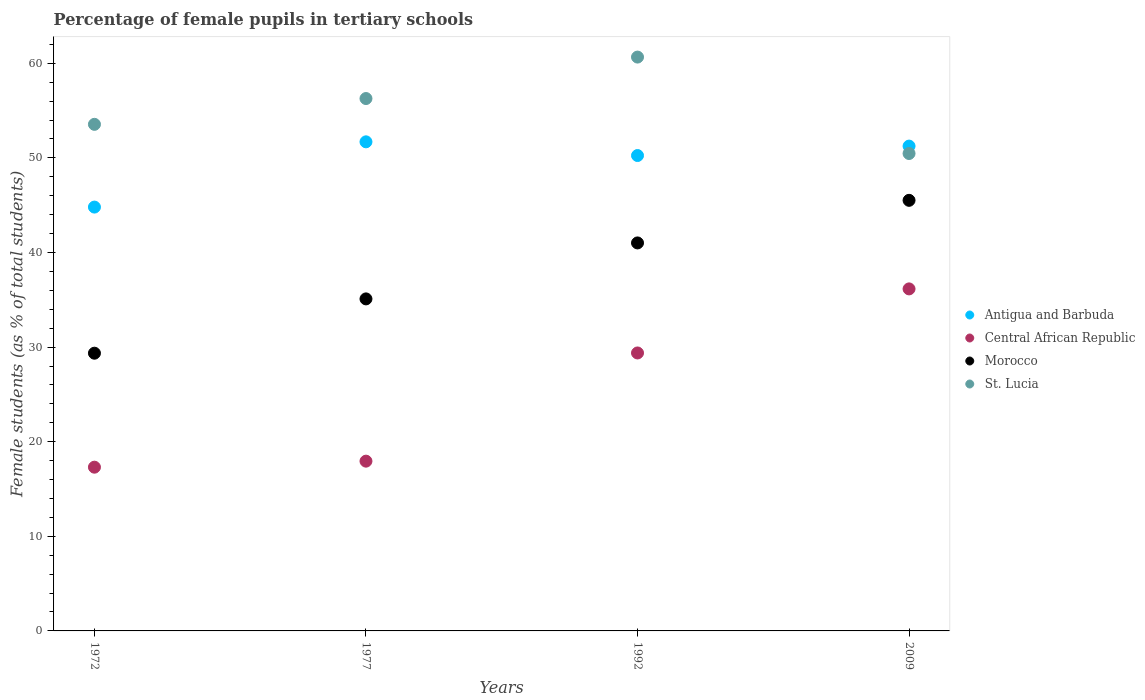How many different coloured dotlines are there?
Keep it short and to the point. 4. Is the number of dotlines equal to the number of legend labels?
Your answer should be compact. Yes. What is the percentage of female pupils in tertiary schools in Central African Republic in 1972?
Ensure brevity in your answer.  17.31. Across all years, what is the maximum percentage of female pupils in tertiary schools in Antigua and Barbuda?
Make the answer very short. 51.7. Across all years, what is the minimum percentage of female pupils in tertiary schools in Morocco?
Ensure brevity in your answer.  29.36. In which year was the percentage of female pupils in tertiary schools in Antigua and Barbuda maximum?
Make the answer very short. 1977. What is the total percentage of female pupils in tertiary schools in Morocco in the graph?
Keep it short and to the point. 150.97. What is the difference between the percentage of female pupils in tertiary schools in St. Lucia in 1972 and that in 1992?
Offer a very short reply. -7.11. What is the difference between the percentage of female pupils in tertiary schools in Antigua and Barbuda in 1992 and the percentage of female pupils in tertiary schools in Central African Republic in 1972?
Make the answer very short. 32.94. What is the average percentage of female pupils in tertiary schools in Central African Republic per year?
Offer a terse response. 25.2. In the year 1972, what is the difference between the percentage of female pupils in tertiary schools in Morocco and percentage of female pupils in tertiary schools in St. Lucia?
Make the answer very short. -24.19. What is the ratio of the percentage of female pupils in tertiary schools in Morocco in 1992 to that in 2009?
Offer a very short reply. 0.9. What is the difference between the highest and the second highest percentage of female pupils in tertiary schools in Central African Republic?
Ensure brevity in your answer.  6.77. What is the difference between the highest and the lowest percentage of female pupils in tertiary schools in Morocco?
Keep it short and to the point. 16.16. In how many years, is the percentage of female pupils in tertiary schools in Morocco greater than the average percentage of female pupils in tertiary schools in Morocco taken over all years?
Offer a terse response. 2. Is the sum of the percentage of female pupils in tertiary schools in Morocco in 1972 and 1977 greater than the maximum percentage of female pupils in tertiary schools in Central African Republic across all years?
Your answer should be very brief. Yes. Is it the case that in every year, the sum of the percentage of female pupils in tertiary schools in Morocco and percentage of female pupils in tertiary schools in Antigua and Barbuda  is greater than the sum of percentage of female pupils in tertiary schools in St. Lucia and percentage of female pupils in tertiary schools in Central African Republic?
Your answer should be very brief. No. Does the percentage of female pupils in tertiary schools in Central African Republic monotonically increase over the years?
Offer a terse response. Yes. Is the percentage of female pupils in tertiary schools in St. Lucia strictly greater than the percentage of female pupils in tertiary schools in Morocco over the years?
Offer a very short reply. Yes. Is the percentage of female pupils in tertiary schools in Morocco strictly less than the percentage of female pupils in tertiary schools in St. Lucia over the years?
Give a very brief answer. Yes. How many years are there in the graph?
Make the answer very short. 4. Are the values on the major ticks of Y-axis written in scientific E-notation?
Offer a very short reply. No. Does the graph contain any zero values?
Your answer should be very brief. No. Does the graph contain grids?
Offer a very short reply. No. Where does the legend appear in the graph?
Your response must be concise. Center right. What is the title of the graph?
Ensure brevity in your answer.  Percentage of female pupils in tertiary schools. Does "Spain" appear as one of the legend labels in the graph?
Your answer should be very brief. No. What is the label or title of the X-axis?
Provide a succinct answer. Years. What is the label or title of the Y-axis?
Your answer should be compact. Female students (as % of total students). What is the Female students (as % of total students) in Antigua and Barbuda in 1972?
Ensure brevity in your answer.  44.8. What is the Female students (as % of total students) of Central African Republic in 1972?
Keep it short and to the point. 17.31. What is the Female students (as % of total students) of Morocco in 1972?
Your response must be concise. 29.36. What is the Female students (as % of total students) in St. Lucia in 1972?
Give a very brief answer. 53.55. What is the Female students (as % of total students) in Antigua and Barbuda in 1977?
Offer a very short reply. 51.7. What is the Female students (as % of total students) in Central African Republic in 1977?
Ensure brevity in your answer.  17.94. What is the Female students (as % of total students) of Morocco in 1977?
Your answer should be compact. 35.09. What is the Female students (as % of total students) in St. Lucia in 1977?
Provide a short and direct response. 56.27. What is the Female students (as % of total students) of Antigua and Barbuda in 1992?
Your answer should be very brief. 50.25. What is the Female students (as % of total students) of Central African Republic in 1992?
Keep it short and to the point. 29.38. What is the Female students (as % of total students) of Morocco in 1992?
Make the answer very short. 41.01. What is the Female students (as % of total students) in St. Lucia in 1992?
Your answer should be very brief. 60.65. What is the Female students (as % of total students) of Antigua and Barbuda in 2009?
Give a very brief answer. 51.24. What is the Female students (as % of total students) of Central African Republic in 2009?
Ensure brevity in your answer.  36.15. What is the Female students (as % of total students) of Morocco in 2009?
Provide a succinct answer. 45.51. What is the Female students (as % of total students) in St. Lucia in 2009?
Provide a succinct answer. 50.46. Across all years, what is the maximum Female students (as % of total students) of Antigua and Barbuda?
Provide a short and direct response. 51.7. Across all years, what is the maximum Female students (as % of total students) of Central African Republic?
Offer a terse response. 36.15. Across all years, what is the maximum Female students (as % of total students) in Morocco?
Give a very brief answer. 45.51. Across all years, what is the maximum Female students (as % of total students) of St. Lucia?
Your response must be concise. 60.65. Across all years, what is the minimum Female students (as % of total students) in Antigua and Barbuda?
Offer a terse response. 44.8. Across all years, what is the minimum Female students (as % of total students) in Central African Republic?
Your response must be concise. 17.31. Across all years, what is the minimum Female students (as % of total students) of Morocco?
Offer a terse response. 29.36. Across all years, what is the minimum Female students (as % of total students) in St. Lucia?
Offer a very short reply. 50.46. What is the total Female students (as % of total students) in Antigua and Barbuda in the graph?
Offer a terse response. 197.99. What is the total Female students (as % of total students) of Central African Republic in the graph?
Keep it short and to the point. 100.78. What is the total Female students (as % of total students) in Morocco in the graph?
Give a very brief answer. 150.97. What is the total Female students (as % of total students) in St. Lucia in the graph?
Your response must be concise. 220.93. What is the difference between the Female students (as % of total students) of Antigua and Barbuda in 1972 and that in 1977?
Provide a succinct answer. -6.9. What is the difference between the Female students (as % of total students) of Central African Republic in 1972 and that in 1977?
Your answer should be very brief. -0.64. What is the difference between the Female students (as % of total students) in Morocco in 1972 and that in 1977?
Make the answer very short. -5.74. What is the difference between the Female students (as % of total students) of St. Lucia in 1972 and that in 1977?
Your response must be concise. -2.73. What is the difference between the Female students (as % of total students) in Antigua and Barbuda in 1972 and that in 1992?
Ensure brevity in your answer.  -5.45. What is the difference between the Female students (as % of total students) of Central African Republic in 1972 and that in 1992?
Your response must be concise. -12.07. What is the difference between the Female students (as % of total students) in Morocco in 1972 and that in 1992?
Offer a terse response. -11.66. What is the difference between the Female students (as % of total students) of St. Lucia in 1972 and that in 1992?
Provide a short and direct response. -7.11. What is the difference between the Female students (as % of total students) in Antigua and Barbuda in 1972 and that in 2009?
Provide a succinct answer. -6.45. What is the difference between the Female students (as % of total students) of Central African Republic in 1972 and that in 2009?
Make the answer very short. -18.84. What is the difference between the Female students (as % of total students) of Morocco in 1972 and that in 2009?
Your answer should be compact. -16.16. What is the difference between the Female students (as % of total students) in St. Lucia in 1972 and that in 2009?
Your answer should be very brief. 3.08. What is the difference between the Female students (as % of total students) in Antigua and Barbuda in 1977 and that in 1992?
Keep it short and to the point. 1.45. What is the difference between the Female students (as % of total students) of Central African Republic in 1977 and that in 1992?
Your answer should be compact. -11.44. What is the difference between the Female students (as % of total students) in Morocco in 1977 and that in 1992?
Your answer should be very brief. -5.92. What is the difference between the Female students (as % of total students) of St. Lucia in 1977 and that in 1992?
Provide a succinct answer. -4.38. What is the difference between the Female students (as % of total students) in Antigua and Barbuda in 1977 and that in 2009?
Offer a very short reply. 0.45. What is the difference between the Female students (as % of total students) of Central African Republic in 1977 and that in 2009?
Your answer should be very brief. -18.21. What is the difference between the Female students (as % of total students) in Morocco in 1977 and that in 2009?
Offer a very short reply. -10.42. What is the difference between the Female students (as % of total students) of St. Lucia in 1977 and that in 2009?
Offer a very short reply. 5.81. What is the difference between the Female students (as % of total students) in Antigua and Barbuda in 1992 and that in 2009?
Your answer should be compact. -1. What is the difference between the Female students (as % of total students) of Central African Republic in 1992 and that in 2009?
Provide a short and direct response. -6.77. What is the difference between the Female students (as % of total students) in Morocco in 1992 and that in 2009?
Make the answer very short. -4.5. What is the difference between the Female students (as % of total students) in St. Lucia in 1992 and that in 2009?
Give a very brief answer. 10.19. What is the difference between the Female students (as % of total students) in Antigua and Barbuda in 1972 and the Female students (as % of total students) in Central African Republic in 1977?
Your answer should be very brief. 26.85. What is the difference between the Female students (as % of total students) in Antigua and Barbuda in 1972 and the Female students (as % of total students) in Morocco in 1977?
Give a very brief answer. 9.7. What is the difference between the Female students (as % of total students) in Antigua and Barbuda in 1972 and the Female students (as % of total students) in St. Lucia in 1977?
Provide a short and direct response. -11.47. What is the difference between the Female students (as % of total students) in Central African Republic in 1972 and the Female students (as % of total students) in Morocco in 1977?
Keep it short and to the point. -17.79. What is the difference between the Female students (as % of total students) of Central African Republic in 1972 and the Female students (as % of total students) of St. Lucia in 1977?
Your answer should be compact. -38.97. What is the difference between the Female students (as % of total students) in Morocco in 1972 and the Female students (as % of total students) in St. Lucia in 1977?
Provide a succinct answer. -26.92. What is the difference between the Female students (as % of total students) in Antigua and Barbuda in 1972 and the Female students (as % of total students) in Central African Republic in 1992?
Give a very brief answer. 15.42. What is the difference between the Female students (as % of total students) in Antigua and Barbuda in 1972 and the Female students (as % of total students) in Morocco in 1992?
Offer a very short reply. 3.79. What is the difference between the Female students (as % of total students) in Antigua and Barbuda in 1972 and the Female students (as % of total students) in St. Lucia in 1992?
Make the answer very short. -15.86. What is the difference between the Female students (as % of total students) of Central African Republic in 1972 and the Female students (as % of total students) of Morocco in 1992?
Ensure brevity in your answer.  -23.7. What is the difference between the Female students (as % of total students) of Central African Republic in 1972 and the Female students (as % of total students) of St. Lucia in 1992?
Your response must be concise. -43.35. What is the difference between the Female students (as % of total students) in Morocco in 1972 and the Female students (as % of total students) in St. Lucia in 1992?
Offer a terse response. -31.3. What is the difference between the Female students (as % of total students) in Antigua and Barbuda in 1972 and the Female students (as % of total students) in Central African Republic in 2009?
Ensure brevity in your answer.  8.65. What is the difference between the Female students (as % of total students) of Antigua and Barbuda in 1972 and the Female students (as % of total students) of Morocco in 2009?
Offer a very short reply. -0.71. What is the difference between the Female students (as % of total students) of Antigua and Barbuda in 1972 and the Female students (as % of total students) of St. Lucia in 2009?
Your answer should be very brief. -5.66. What is the difference between the Female students (as % of total students) of Central African Republic in 1972 and the Female students (as % of total students) of Morocco in 2009?
Provide a short and direct response. -28.21. What is the difference between the Female students (as % of total students) of Central African Republic in 1972 and the Female students (as % of total students) of St. Lucia in 2009?
Offer a very short reply. -33.16. What is the difference between the Female students (as % of total students) in Morocco in 1972 and the Female students (as % of total students) in St. Lucia in 2009?
Offer a very short reply. -21.11. What is the difference between the Female students (as % of total students) of Antigua and Barbuda in 1977 and the Female students (as % of total students) of Central African Republic in 1992?
Ensure brevity in your answer.  22.32. What is the difference between the Female students (as % of total students) of Antigua and Barbuda in 1977 and the Female students (as % of total students) of Morocco in 1992?
Provide a short and direct response. 10.69. What is the difference between the Female students (as % of total students) of Antigua and Barbuda in 1977 and the Female students (as % of total students) of St. Lucia in 1992?
Your response must be concise. -8.96. What is the difference between the Female students (as % of total students) in Central African Republic in 1977 and the Female students (as % of total students) in Morocco in 1992?
Make the answer very short. -23.07. What is the difference between the Female students (as % of total students) in Central African Republic in 1977 and the Female students (as % of total students) in St. Lucia in 1992?
Give a very brief answer. -42.71. What is the difference between the Female students (as % of total students) in Morocco in 1977 and the Female students (as % of total students) in St. Lucia in 1992?
Ensure brevity in your answer.  -25.56. What is the difference between the Female students (as % of total students) in Antigua and Barbuda in 1977 and the Female students (as % of total students) in Central African Republic in 2009?
Keep it short and to the point. 15.54. What is the difference between the Female students (as % of total students) in Antigua and Barbuda in 1977 and the Female students (as % of total students) in Morocco in 2009?
Provide a succinct answer. 6.18. What is the difference between the Female students (as % of total students) of Antigua and Barbuda in 1977 and the Female students (as % of total students) of St. Lucia in 2009?
Ensure brevity in your answer.  1.23. What is the difference between the Female students (as % of total students) of Central African Republic in 1977 and the Female students (as % of total students) of Morocco in 2009?
Give a very brief answer. -27.57. What is the difference between the Female students (as % of total students) of Central African Republic in 1977 and the Female students (as % of total students) of St. Lucia in 2009?
Ensure brevity in your answer.  -32.52. What is the difference between the Female students (as % of total students) of Morocco in 1977 and the Female students (as % of total students) of St. Lucia in 2009?
Offer a terse response. -15.37. What is the difference between the Female students (as % of total students) in Antigua and Barbuda in 1992 and the Female students (as % of total students) in Central African Republic in 2009?
Provide a short and direct response. 14.1. What is the difference between the Female students (as % of total students) of Antigua and Barbuda in 1992 and the Female students (as % of total students) of Morocco in 2009?
Your answer should be compact. 4.74. What is the difference between the Female students (as % of total students) of Antigua and Barbuda in 1992 and the Female students (as % of total students) of St. Lucia in 2009?
Provide a succinct answer. -0.21. What is the difference between the Female students (as % of total students) of Central African Republic in 1992 and the Female students (as % of total students) of Morocco in 2009?
Provide a short and direct response. -16.13. What is the difference between the Female students (as % of total students) of Central African Republic in 1992 and the Female students (as % of total students) of St. Lucia in 2009?
Provide a short and direct response. -21.08. What is the difference between the Female students (as % of total students) of Morocco in 1992 and the Female students (as % of total students) of St. Lucia in 2009?
Provide a short and direct response. -9.45. What is the average Female students (as % of total students) in Antigua and Barbuda per year?
Your answer should be compact. 49.5. What is the average Female students (as % of total students) in Central African Republic per year?
Keep it short and to the point. 25.2. What is the average Female students (as % of total students) of Morocco per year?
Offer a very short reply. 37.74. What is the average Female students (as % of total students) in St. Lucia per year?
Make the answer very short. 55.23. In the year 1972, what is the difference between the Female students (as % of total students) in Antigua and Barbuda and Female students (as % of total students) in Central African Republic?
Make the answer very short. 27.49. In the year 1972, what is the difference between the Female students (as % of total students) in Antigua and Barbuda and Female students (as % of total students) in Morocco?
Offer a terse response. 15.44. In the year 1972, what is the difference between the Female students (as % of total students) of Antigua and Barbuda and Female students (as % of total students) of St. Lucia?
Keep it short and to the point. -8.75. In the year 1972, what is the difference between the Female students (as % of total students) in Central African Republic and Female students (as % of total students) in Morocco?
Your answer should be very brief. -12.05. In the year 1972, what is the difference between the Female students (as % of total students) of Central African Republic and Female students (as % of total students) of St. Lucia?
Your answer should be very brief. -36.24. In the year 1972, what is the difference between the Female students (as % of total students) in Morocco and Female students (as % of total students) in St. Lucia?
Offer a very short reply. -24.19. In the year 1977, what is the difference between the Female students (as % of total students) in Antigua and Barbuda and Female students (as % of total students) in Central African Republic?
Make the answer very short. 33.75. In the year 1977, what is the difference between the Female students (as % of total students) in Antigua and Barbuda and Female students (as % of total students) in Morocco?
Your answer should be compact. 16.6. In the year 1977, what is the difference between the Female students (as % of total students) in Antigua and Barbuda and Female students (as % of total students) in St. Lucia?
Offer a very short reply. -4.58. In the year 1977, what is the difference between the Female students (as % of total students) in Central African Republic and Female students (as % of total students) in Morocco?
Your response must be concise. -17.15. In the year 1977, what is the difference between the Female students (as % of total students) of Central African Republic and Female students (as % of total students) of St. Lucia?
Provide a short and direct response. -38.33. In the year 1977, what is the difference between the Female students (as % of total students) of Morocco and Female students (as % of total students) of St. Lucia?
Give a very brief answer. -21.18. In the year 1992, what is the difference between the Female students (as % of total students) of Antigua and Barbuda and Female students (as % of total students) of Central African Republic?
Your response must be concise. 20.87. In the year 1992, what is the difference between the Female students (as % of total students) in Antigua and Barbuda and Female students (as % of total students) in Morocco?
Make the answer very short. 9.24. In the year 1992, what is the difference between the Female students (as % of total students) in Antigua and Barbuda and Female students (as % of total students) in St. Lucia?
Provide a short and direct response. -10.41. In the year 1992, what is the difference between the Female students (as % of total students) of Central African Republic and Female students (as % of total students) of Morocco?
Ensure brevity in your answer.  -11.63. In the year 1992, what is the difference between the Female students (as % of total students) of Central African Republic and Female students (as % of total students) of St. Lucia?
Your response must be concise. -31.27. In the year 1992, what is the difference between the Female students (as % of total students) in Morocco and Female students (as % of total students) in St. Lucia?
Keep it short and to the point. -19.64. In the year 2009, what is the difference between the Female students (as % of total students) in Antigua and Barbuda and Female students (as % of total students) in Central African Republic?
Keep it short and to the point. 15.09. In the year 2009, what is the difference between the Female students (as % of total students) in Antigua and Barbuda and Female students (as % of total students) in Morocco?
Your answer should be very brief. 5.73. In the year 2009, what is the difference between the Female students (as % of total students) in Antigua and Barbuda and Female students (as % of total students) in St. Lucia?
Offer a very short reply. 0.78. In the year 2009, what is the difference between the Female students (as % of total students) in Central African Republic and Female students (as % of total students) in Morocco?
Your answer should be very brief. -9.36. In the year 2009, what is the difference between the Female students (as % of total students) of Central African Republic and Female students (as % of total students) of St. Lucia?
Make the answer very short. -14.31. In the year 2009, what is the difference between the Female students (as % of total students) of Morocco and Female students (as % of total students) of St. Lucia?
Provide a short and direct response. -4.95. What is the ratio of the Female students (as % of total students) in Antigua and Barbuda in 1972 to that in 1977?
Offer a very short reply. 0.87. What is the ratio of the Female students (as % of total students) in Central African Republic in 1972 to that in 1977?
Make the answer very short. 0.96. What is the ratio of the Female students (as % of total students) of Morocco in 1972 to that in 1977?
Keep it short and to the point. 0.84. What is the ratio of the Female students (as % of total students) in St. Lucia in 1972 to that in 1977?
Make the answer very short. 0.95. What is the ratio of the Female students (as % of total students) of Antigua and Barbuda in 1972 to that in 1992?
Offer a very short reply. 0.89. What is the ratio of the Female students (as % of total students) in Central African Republic in 1972 to that in 1992?
Your response must be concise. 0.59. What is the ratio of the Female students (as % of total students) of Morocco in 1972 to that in 1992?
Keep it short and to the point. 0.72. What is the ratio of the Female students (as % of total students) of St. Lucia in 1972 to that in 1992?
Give a very brief answer. 0.88. What is the ratio of the Female students (as % of total students) in Antigua and Barbuda in 1972 to that in 2009?
Your response must be concise. 0.87. What is the ratio of the Female students (as % of total students) in Central African Republic in 1972 to that in 2009?
Your answer should be very brief. 0.48. What is the ratio of the Female students (as % of total students) of Morocco in 1972 to that in 2009?
Your response must be concise. 0.65. What is the ratio of the Female students (as % of total students) in St. Lucia in 1972 to that in 2009?
Offer a very short reply. 1.06. What is the ratio of the Female students (as % of total students) of Antigua and Barbuda in 1977 to that in 1992?
Your answer should be very brief. 1.03. What is the ratio of the Female students (as % of total students) of Central African Republic in 1977 to that in 1992?
Offer a terse response. 0.61. What is the ratio of the Female students (as % of total students) of Morocco in 1977 to that in 1992?
Your response must be concise. 0.86. What is the ratio of the Female students (as % of total students) in St. Lucia in 1977 to that in 1992?
Your response must be concise. 0.93. What is the ratio of the Female students (as % of total students) of Antigua and Barbuda in 1977 to that in 2009?
Provide a short and direct response. 1.01. What is the ratio of the Female students (as % of total students) of Central African Republic in 1977 to that in 2009?
Keep it short and to the point. 0.5. What is the ratio of the Female students (as % of total students) in Morocco in 1977 to that in 2009?
Provide a short and direct response. 0.77. What is the ratio of the Female students (as % of total students) of St. Lucia in 1977 to that in 2009?
Provide a succinct answer. 1.12. What is the ratio of the Female students (as % of total students) in Antigua and Barbuda in 1992 to that in 2009?
Your answer should be compact. 0.98. What is the ratio of the Female students (as % of total students) in Central African Republic in 1992 to that in 2009?
Give a very brief answer. 0.81. What is the ratio of the Female students (as % of total students) in Morocco in 1992 to that in 2009?
Your answer should be very brief. 0.9. What is the ratio of the Female students (as % of total students) in St. Lucia in 1992 to that in 2009?
Offer a terse response. 1.2. What is the difference between the highest and the second highest Female students (as % of total students) in Antigua and Barbuda?
Ensure brevity in your answer.  0.45. What is the difference between the highest and the second highest Female students (as % of total students) in Central African Republic?
Offer a very short reply. 6.77. What is the difference between the highest and the second highest Female students (as % of total students) in Morocco?
Give a very brief answer. 4.5. What is the difference between the highest and the second highest Female students (as % of total students) of St. Lucia?
Ensure brevity in your answer.  4.38. What is the difference between the highest and the lowest Female students (as % of total students) in Antigua and Barbuda?
Give a very brief answer. 6.9. What is the difference between the highest and the lowest Female students (as % of total students) in Central African Republic?
Provide a succinct answer. 18.84. What is the difference between the highest and the lowest Female students (as % of total students) of Morocco?
Offer a very short reply. 16.16. What is the difference between the highest and the lowest Female students (as % of total students) of St. Lucia?
Provide a short and direct response. 10.19. 